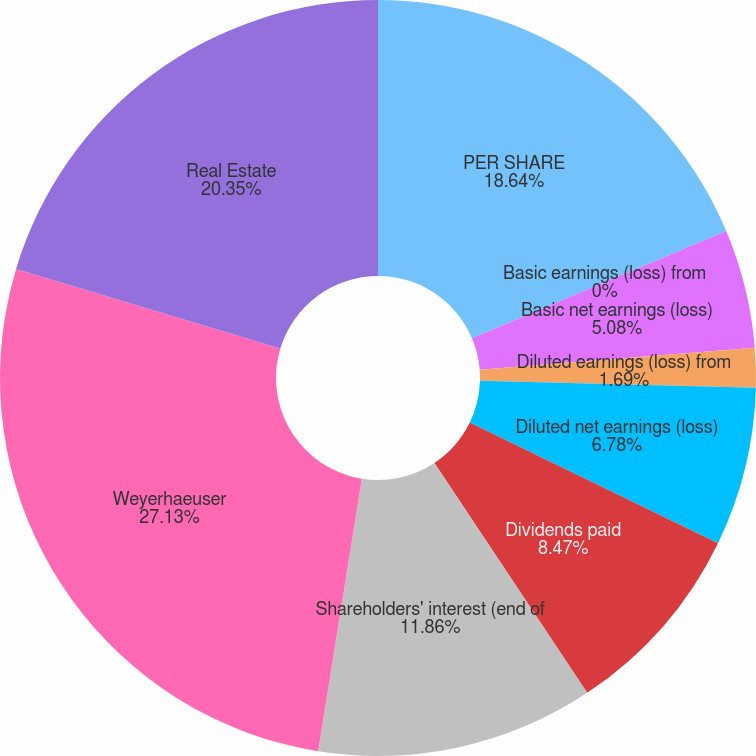Convert chart to OTSL. <chart><loc_0><loc_0><loc_500><loc_500><pie_chart><fcel>PER SHARE<fcel>Basic earnings (loss) from<fcel>Basic net earnings (loss)<fcel>Diluted earnings (loss) from<fcel>Diluted net earnings (loss)<fcel>Dividends paid<fcel>Shareholders' interest (end of<fcel>Weyerhaeuser<fcel>Real Estate<nl><fcel>18.64%<fcel>0.0%<fcel>5.08%<fcel>1.69%<fcel>6.78%<fcel>8.47%<fcel>11.86%<fcel>27.12%<fcel>20.34%<nl></chart> 